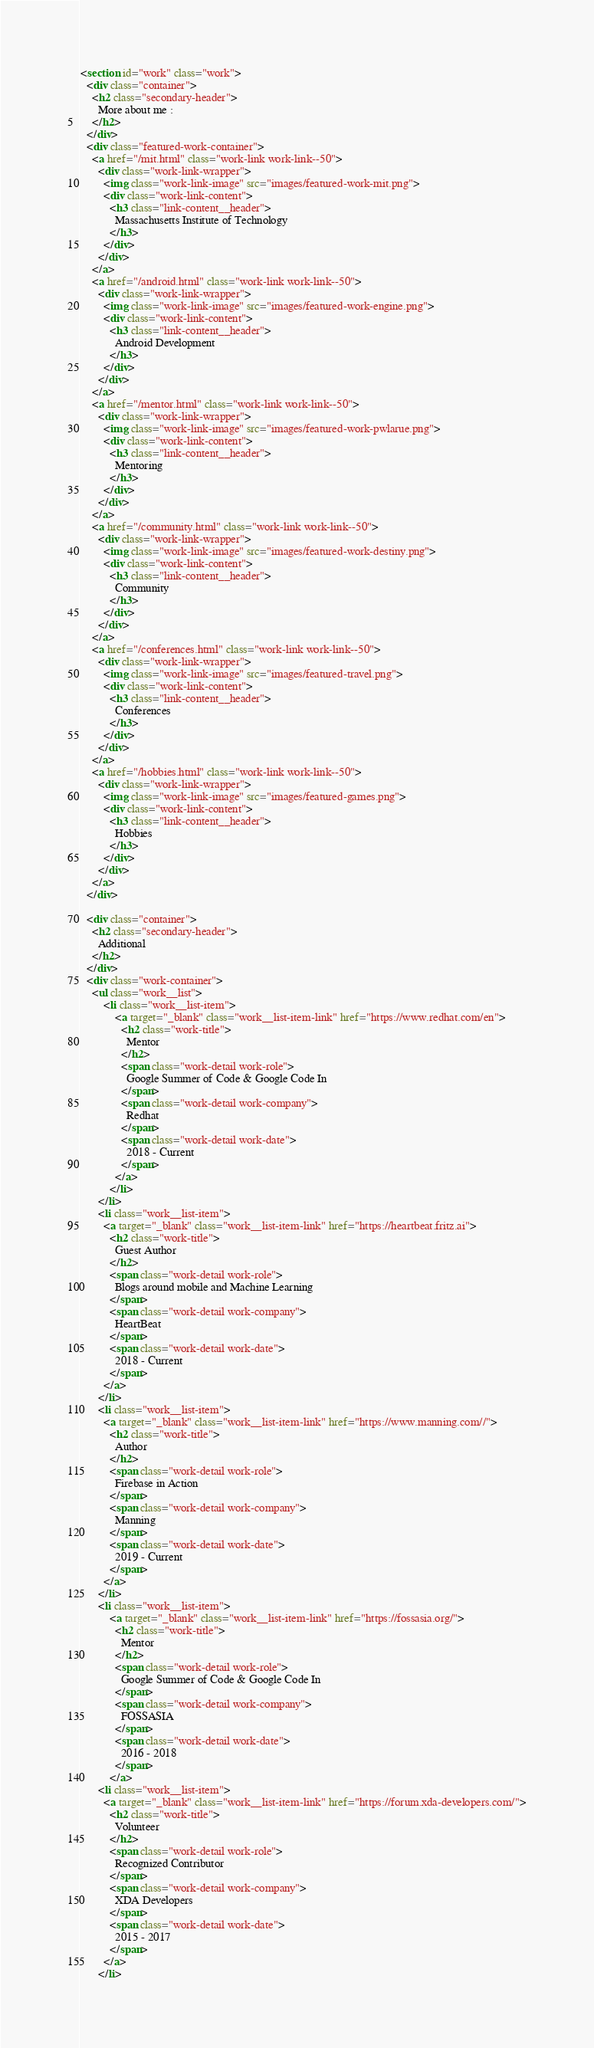<code> <loc_0><loc_0><loc_500><loc_500><_HTML_><section id="work" class="work">
  <div class="container">
    <h2 class="secondary-header">
      More about me : 
    </h2>
  </div>
  <div class="featured-work-container">
    <a href="/mit.html" class="work-link work-link--50">
      <div class="work-link-wrapper">
        <img class="work-link-image" src="images/featured-work-mit.png">
        <div class="work-link-content">
          <h3 class="link-content__header">
            Massachusetts Institute of Technology
          </h3>
        </div>
      </div>
    </a>
    <a href="/android.html" class="work-link work-link--50">
      <div class="work-link-wrapper">
        <img class="work-link-image" src="images/featured-work-engine.png">
        <div class="work-link-content">
          <h3 class="link-content__header">
            Android Development
          </h3>
        </div>
      </div>
    </a>
    <a href="/mentor.html" class="work-link work-link--50">
      <div class="work-link-wrapper">
        <img class="work-link-image" src="images/featured-work-pwlarue.png">
        <div class="work-link-content">
          <h3 class="link-content__header">
            Mentoring
          </h3>
        </div>
      </div>
    </a>
    <a href="/community.html" class="work-link work-link--50">
      <div class="work-link-wrapper">
        <img class="work-link-image" src="images/featured-work-destiny.png">
        <div class="work-link-content">
          <h3 class="link-content__header">
            Community
          </h3>
        </div>
      </div>
    </a>
    <a href="/conferences.html" class="work-link work-link--50">
      <div class="work-link-wrapper">
        <img class="work-link-image" src="images/featured-travel.png">
        <div class="work-link-content">
          <h3 class="link-content__header">
            Conferences
          </h3>
        </div>
      </div>
    </a>
    <a href="/hobbies.html" class="work-link work-link--50">
      <div class="work-link-wrapper">
        <img class="work-link-image" src="images/featured-games.png">
        <div class="work-link-content">
          <h3 class="link-content__header">
            Hobbies
          </h3>
        </div>
      </div>
    </a>
  </div>

  <div class="container">
    <h2 class="secondary-header">
      Additional
    </h2>
  </div>
  <div class="work-container">
    <ul class="work__list">
        <li class="work__list-item">
            <a target="_blank" class="work__list-item-link" href="https://www.redhat.com/en">
              <h2 class="work-title">
                Mentor
              </h2>
              <span class="work-detail work-role">
                Google Summer of Code & Google Code In
              </span>
              <span class="work-detail work-company">
                Redhat
              </span>
              <span class="work-detail work-date">
                2018 - Current
              </span>
            </a>
          </li>
      </li>
      <li class="work__list-item">
        <a target="_blank" class="work__list-item-link" href="https://heartbeat.fritz.ai">
          <h2 class="work-title">
            Guest Author
          </h2>
          <span class="work-detail work-role">
            Blogs around mobile and Machine Learning
          </span>
          <span class="work-detail work-company">
            HeartBeat
          </span>
          <span class="work-detail work-date">
            2018 - Current
          </span>
        </a>
      </li>
      <li class="work__list-item">
        <a target="_blank" class="work__list-item-link" href="https://www.manning.com//">
          <h2 class="work-title">
            Author
          </h2>
          <span class="work-detail work-role">
            Firebase in Action
          </span>
          <span class="work-detail work-company">
            Manning
          </span>
          <span class="work-detail work-date">
            2019 - Current
          </span>
        </a>
      </li>
      <li class="work__list-item">
          <a target="_blank" class="work__list-item-link" href="https://fossasia.org/">
            <h2 class="work-title">
              Mentor
            </h2>
            <span class="work-detail work-role">
              Google Summer of Code & Google Code In
            </span>
            <span class="work-detail work-company">
              FOSSASIA
            </span>
            <span class="work-detail work-date">
              2016 - 2018
            </span>
          </a>
      <li class="work__list-item">
        <a target="_blank" class="work__list-item-link" href="https://forum.xda-developers.com/">
          <h2 class="work-title">
            Volunteer
          </h2>
          <span class="work-detail work-role">
            Recognized Contributor
          </span>
          <span class="work-detail work-company">
            XDA Developers
          </span>
          <span class="work-detail work-date">
            2015 - 2017
          </span>
        </a>
      </li></code> 